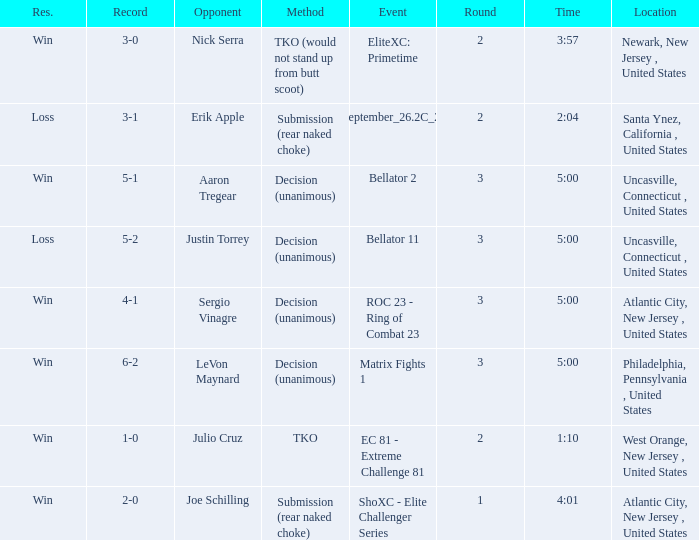Who was the opponent when there was a TKO method? Julio Cruz. 